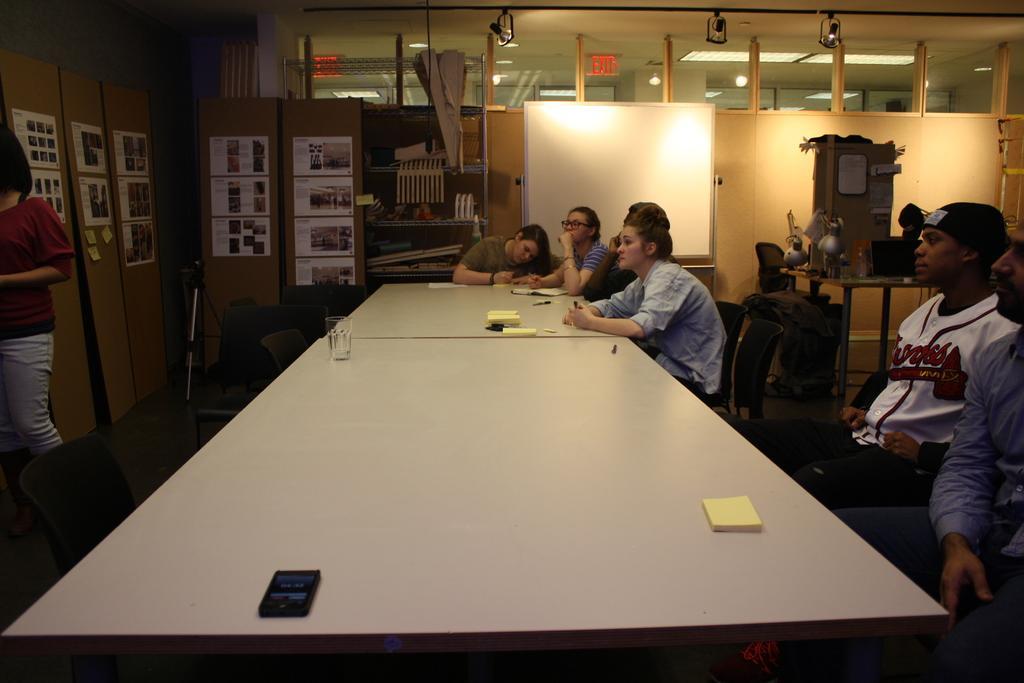Please provide a concise description of this image. Here we can see a group of people are sitting on the chair, and in front here is the table and books and glass on it, and here is the board, and here are the books in the rack, and here a person is standing. 